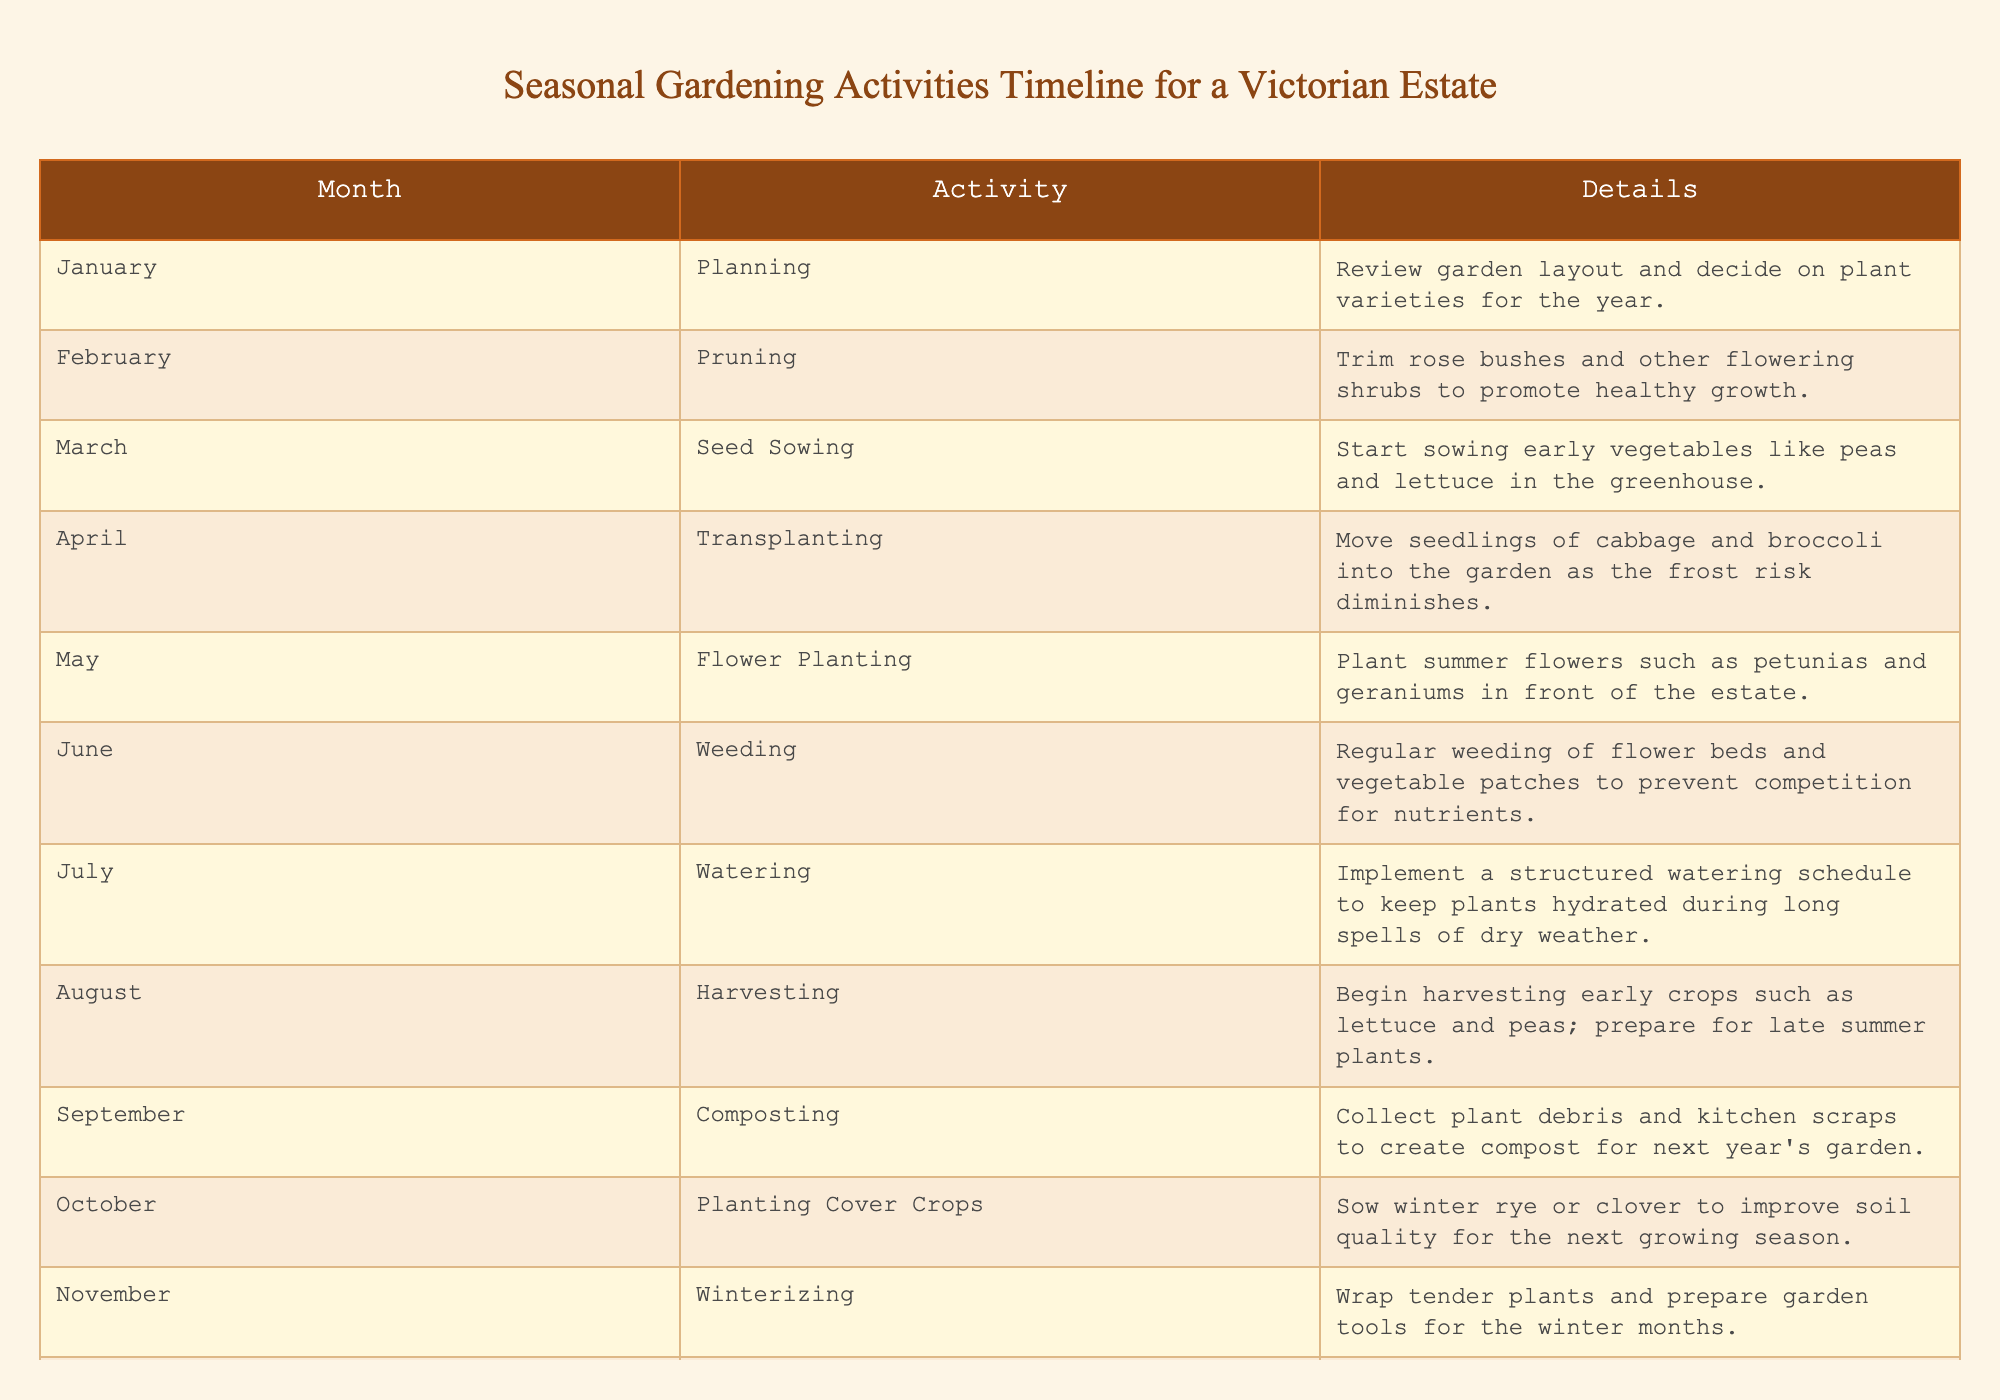What's the activity scheduled for May? Looking at the table, I can see that in May, the scheduled activity is flower planting, specifically planting summer flowers such as petunias and geraniums in front of the estate.
Answer: Flower Planting In which month do we begin harvesting crops? According to the table, the harvesting of early crops such as lettuce and peas starts in August.
Answer: August What is the total number of activities listed in the table? The table lists activities for each month from January to December, resulting in 12 distinct activities throughout the year.
Answer: 12 Is pruning done before or after seed sowing? Pruning occurs in February, while seed sowing begins in March, indicating that pruning is done before seed sowing.
Answer: Before Which month requires weeding activities? The table indicates that weeding is scheduled for June, focusing on flower beds and vegetable patches to ensure plants receive adequate nutrients.
Answer: June What are the two main activities in the spring months? The spring months, which are March, April, and May, list seed sowing (March) and transplanting (April) as the two activities, with flower planting occurring in May.
Answer: Seed Sowing and Transplanting Does the garden have any activity planned for December? Yes, the table shows that December is designated for resting, allowing time to reflect on the year's gardening success and plan for improvements.
Answer: Yes What is the difference between the activities in July and August? In July, the activity focuses on watering, while in August it shifts to harvesting. Therefore, the difference is that July is about maintaining plant hydration and August focuses on harvesting crops.
Answer: Watering and Harvesting 